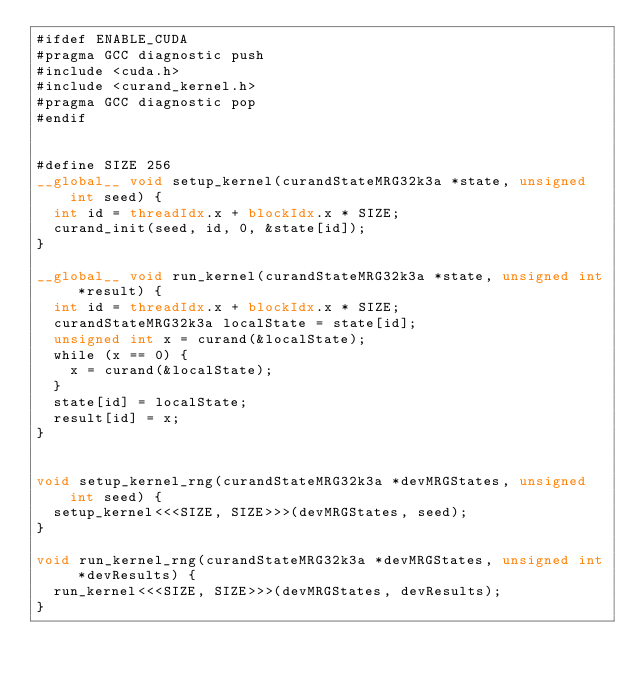Convert code to text. <code><loc_0><loc_0><loc_500><loc_500><_Cuda_>#ifdef ENABLE_CUDA
#pragma GCC diagnostic push
#include <cuda.h>
#include <curand_kernel.h>
#pragma GCC diagnostic pop
#endif


#define SIZE 256
__global__ void setup_kernel(curandStateMRG32k3a *state, unsigned int seed) {
  int id = threadIdx.x + blockIdx.x * SIZE; 
  curand_init(seed, id, 0, &state[id]);
} 

__global__ void run_kernel(curandStateMRG32k3a *state, unsigned int *result) { 
  int id = threadIdx.x + blockIdx.x * SIZE;
  curandStateMRG32k3a localState = state[id];
  unsigned int x = curand(&localState); 
  while (x == 0) {
    x = curand(&localState); 
  }
  state[id] = localState; 
  result[id] = x; 
}


void setup_kernel_rng(curandStateMRG32k3a *devMRGStates, unsigned int seed) {
  setup_kernel<<<SIZE, SIZE>>>(devMRGStates, seed);
}

void run_kernel_rng(curandStateMRG32k3a *devMRGStates, unsigned int *devResults) {
  run_kernel<<<SIZE, SIZE>>>(devMRGStates, devResults);
}
</code> 